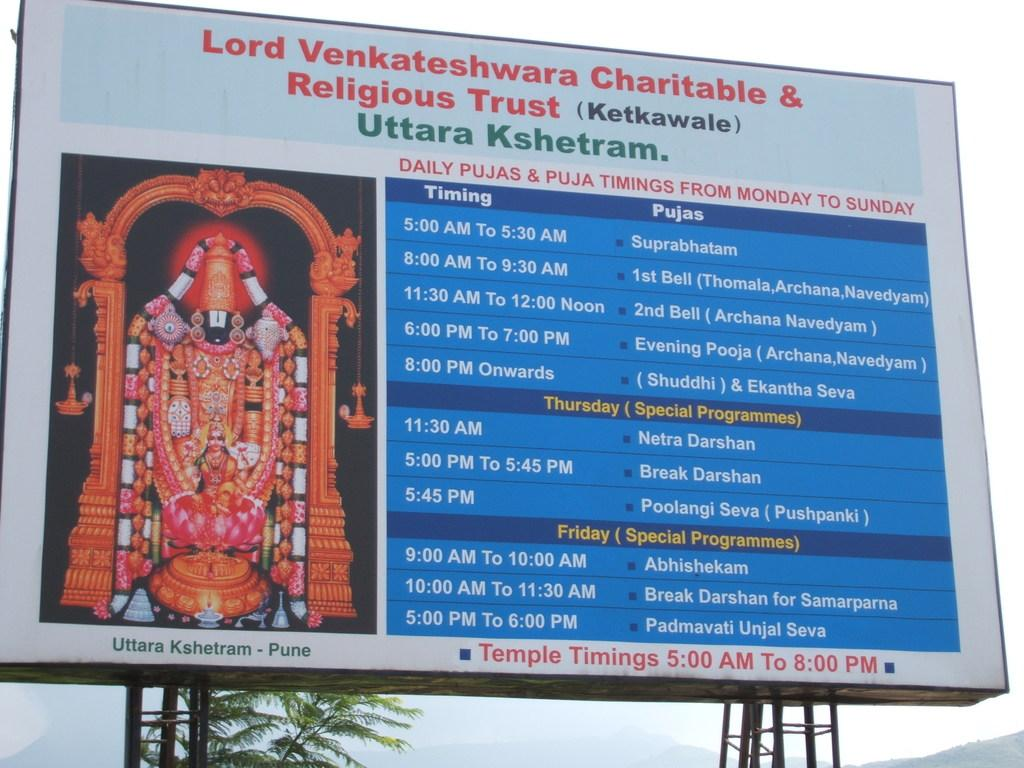<image>
Share a concise interpretation of the image provided. a billboard that says 'lord venkateshwara charitable & religious trust' on it 